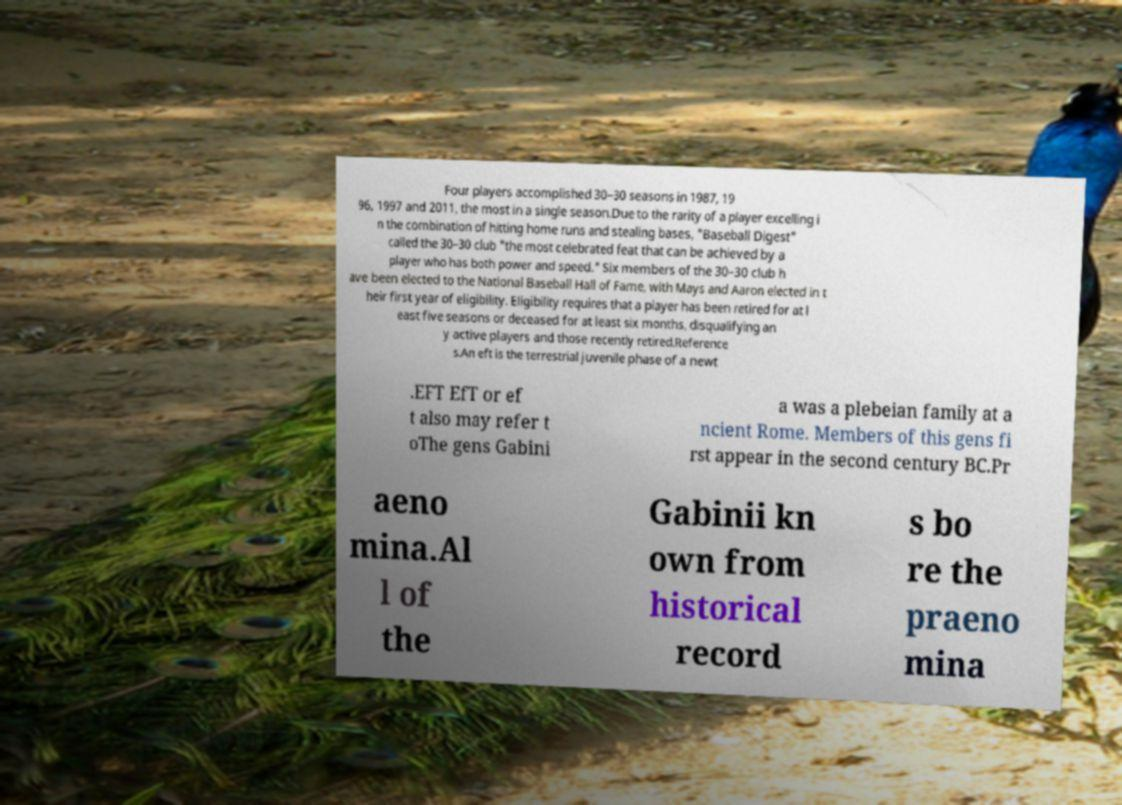There's text embedded in this image that I need extracted. Can you transcribe it verbatim? Four players accomplished 30–30 seasons in 1987, 19 96, 1997 and 2011, the most in a single season.Due to the rarity of a player excelling i n the combination of hitting home runs and stealing bases, "Baseball Digest" called the 30–30 club "the most celebrated feat that can be achieved by a player who has both power and speed." Six members of the 30–30 club h ave been elected to the National Baseball Hall of Fame, with Mays and Aaron elected in t heir first year of eligibility. Eligibility requires that a player has been retired for at l east five seasons or deceased for at least six months, disqualifying an y active players and those recently retired.Reference s.An eft is the terrestrial juvenile phase of a newt .EFT EfT or ef t also may refer t oThe gens Gabini a was a plebeian family at a ncient Rome. Members of this gens fi rst appear in the second century BC.Pr aeno mina.Al l of the Gabinii kn own from historical record s bo re the praeno mina 